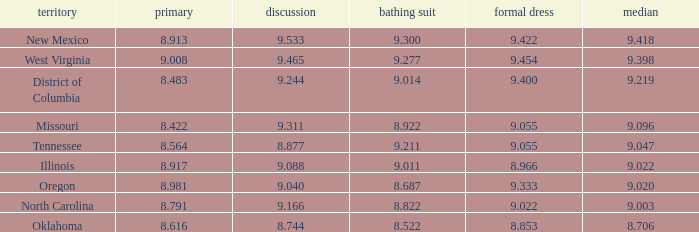Name the preliminary for north carolina 8.791. 